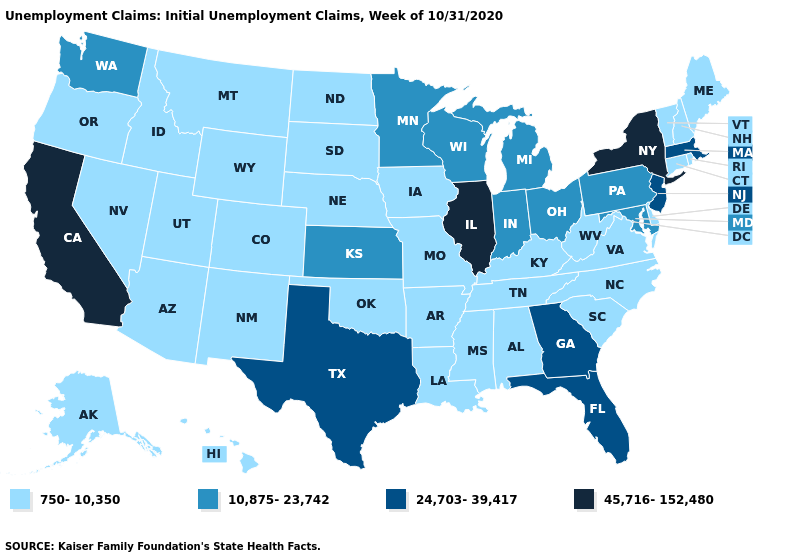Does the first symbol in the legend represent the smallest category?
Short answer required. Yes. Name the states that have a value in the range 45,716-152,480?
Short answer required. California, Illinois, New York. Name the states that have a value in the range 10,875-23,742?
Quick response, please. Indiana, Kansas, Maryland, Michigan, Minnesota, Ohio, Pennsylvania, Washington, Wisconsin. Among the states that border Rhode Island , which have the highest value?
Answer briefly. Massachusetts. Does Delaware have the highest value in the USA?
Write a very short answer. No. Does the map have missing data?
Answer briefly. No. Does Ohio have the lowest value in the USA?
Be succinct. No. Does Kansas have the same value as Wisconsin?
Be succinct. Yes. Which states hav the highest value in the West?
Short answer required. California. What is the highest value in states that border Idaho?
Quick response, please. 10,875-23,742. Does Oklahoma have the lowest value in the South?
Keep it brief. Yes. Which states have the lowest value in the USA?
Answer briefly. Alabama, Alaska, Arizona, Arkansas, Colorado, Connecticut, Delaware, Hawaii, Idaho, Iowa, Kentucky, Louisiana, Maine, Mississippi, Missouri, Montana, Nebraska, Nevada, New Hampshire, New Mexico, North Carolina, North Dakota, Oklahoma, Oregon, Rhode Island, South Carolina, South Dakota, Tennessee, Utah, Vermont, Virginia, West Virginia, Wyoming. What is the highest value in the South ?
Quick response, please. 24,703-39,417. What is the value of Colorado?
Answer briefly. 750-10,350. What is the value of Texas?
Be succinct. 24,703-39,417. 